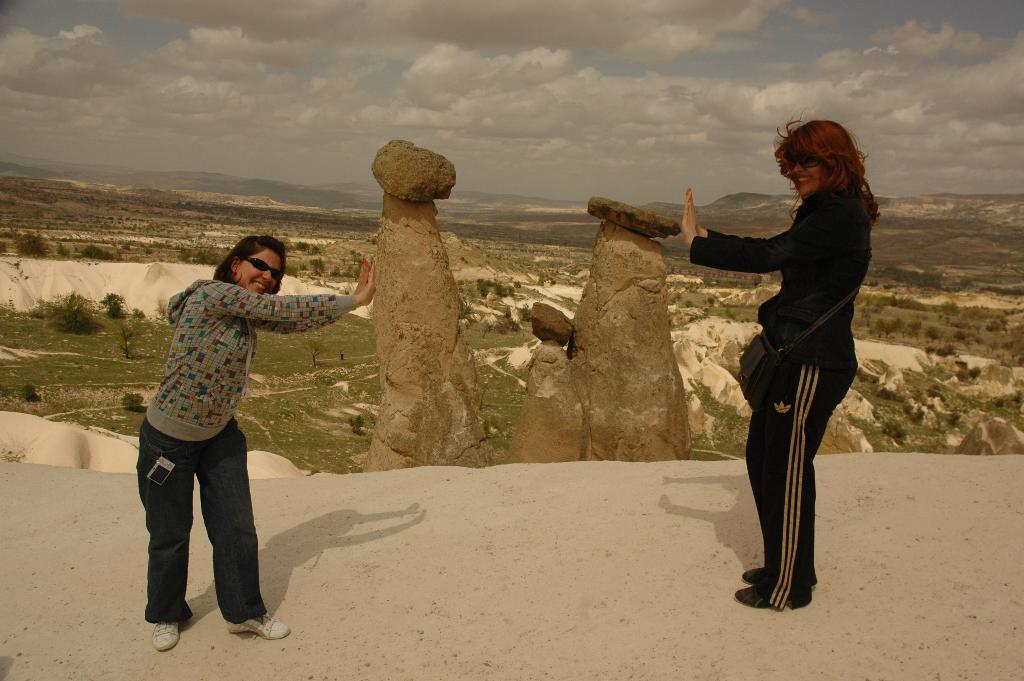How many people are in the image? There are two people standing in the image. Where are the people located in the image? The people are standing on a path. What other objects or features can be seen in the image? There are rocks visible in the image, and there are hills and the sky in the background. What type of ice can be seen melting on the engine of the car in the image? There is no car or ice present in the image; it features two people standing on a path with rocks, hills, and the sky in the background. 